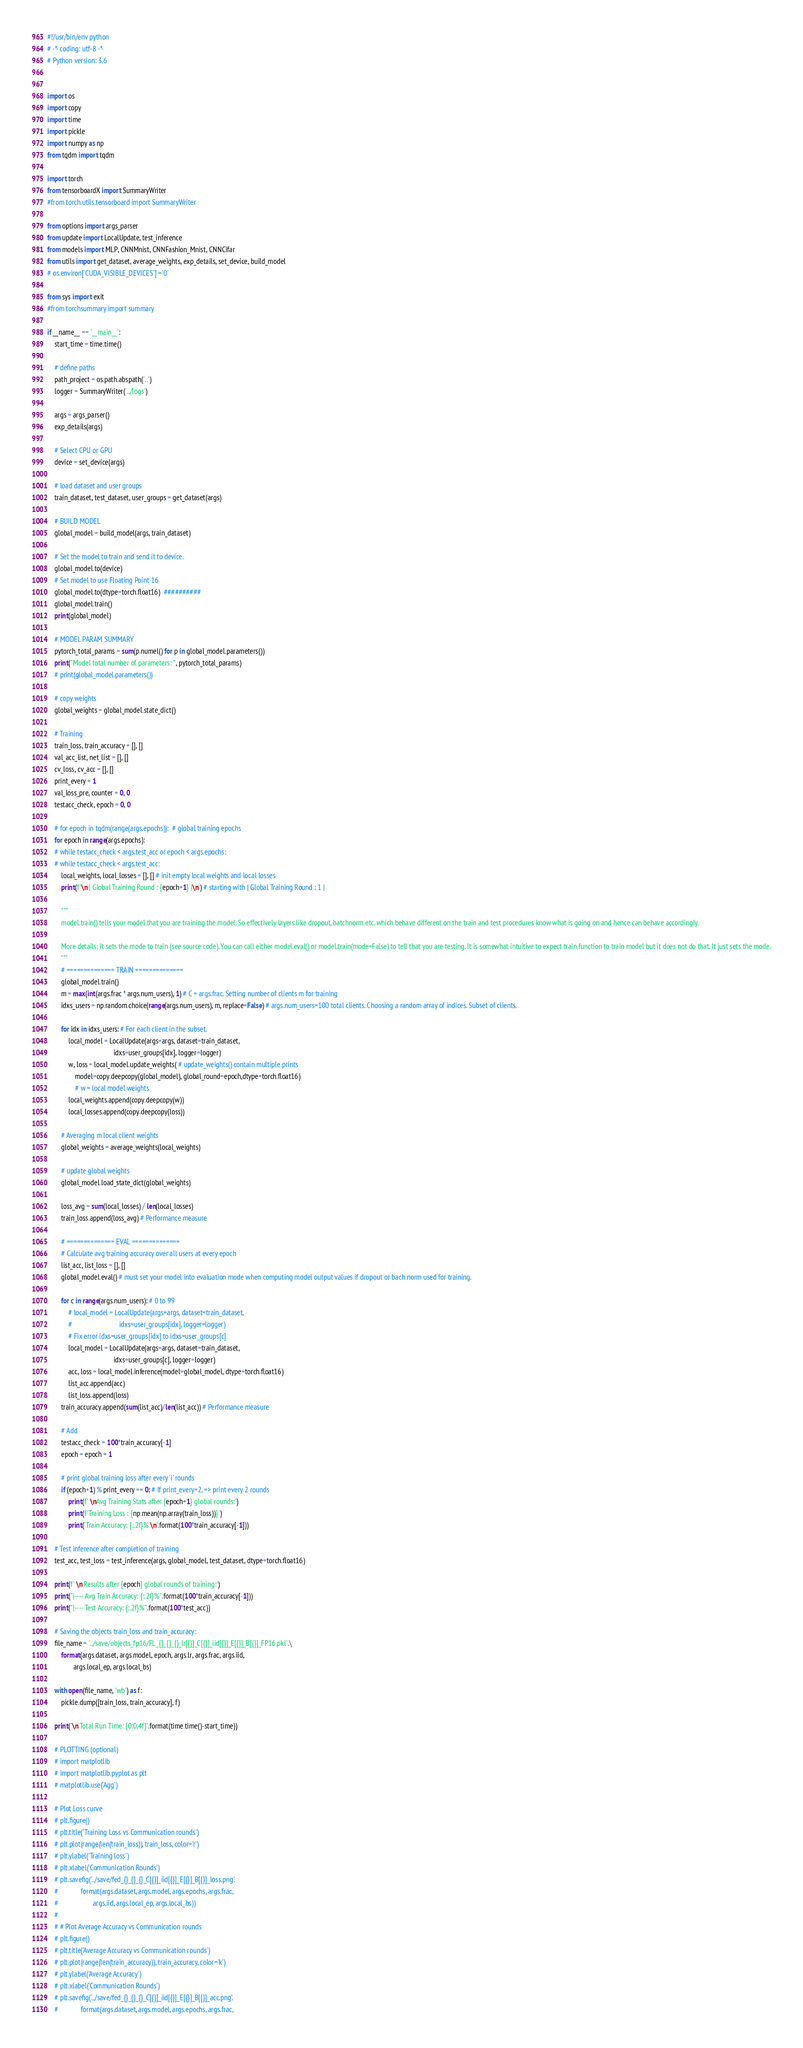<code> <loc_0><loc_0><loc_500><loc_500><_Python_>#!/usr/bin/env python
# -*- coding: utf-8 -*-
# Python version: 3.6


import os
import copy
import time
import pickle
import numpy as np
from tqdm import tqdm

import torch
from tensorboardX import SummaryWriter 
#from torch.utils.tensorboard import SummaryWriter

from options import args_parser
from update import LocalUpdate, test_inference
from models import MLP, CNNMnist, CNNFashion_Mnist, CNNCifar
from utils import get_dataset, average_weights, exp_details, set_device, build_model
# os.environ['CUDA_VISIBLE_DEVICES'] ='0'

from sys import exit
#from torchsummary import summary

if __name__ == '__main__':
    start_time = time.time()

    # define paths
    path_project = os.path.abspath('..')
    logger = SummaryWriter('../logs')

    args = args_parser()
    exp_details(args)

    # Select CPU or GPU
    device = set_device(args)

    # load dataset and user groups
    train_dataset, test_dataset, user_groups = get_dataset(args)

    # BUILD MODEL
    global_model = build_model(args, train_dataset)

    # Set the model to train and send it to device.
    global_model.to(device)
    # Set model to use Floating Point 16
    global_model.to(dtype=torch.float16)  ##########
    global_model.train()
    print(global_model)
    
    # MODEL PARAM SUMMARY
    pytorch_total_params = sum(p.numel() for p in global_model.parameters())
    print("Model total number of parameters: ", pytorch_total_params)
    # print(global_model.parameters())

    # copy weights
    global_weights = global_model.state_dict()

    # Training
    train_loss, train_accuracy = [], []
    val_acc_list, net_list = [], []
    cv_loss, cv_acc = [], []
    print_every = 1
    val_loss_pre, counter = 0, 0
    testacc_check, epoch = 0, 0 

    # for epoch in tqdm(range(args.epochs)):  # global training epochs
    for epoch in range(args.epochs):
    # while testacc_check < args.test_acc or epoch < args.epochs:
    # while testacc_check < args.test_acc:
        local_weights, local_losses = [], [] # init empty local weights and local losses
        print(f'\n | Global Training Round : {epoch+1} |\n') # starting with | Global Training Round : 1 |

        """
        model.train() tells your model that you are training the model. So effectively layers like dropout, batchnorm etc. which behave different on the train and test procedures know what is going on and hence can behave accordingly.

        More details: It sets the mode to train (see source code). You can call either model.eval() or model.train(mode=False) to tell that you are testing. It is somewhat intuitive to expect train function to train model but it does not do that. It just sets the mode.
        """
        # ============== TRAIN ============== 
        global_model.train()
        m = max(int(args.frac * args.num_users), 1) # C = args.frac. Setting number of clients m for training
        idxs_users = np.random.choice(range(args.num_users), m, replace=False) # args.num_users=100 total clients. Choosing a random array of indices. Subset of clients.

        for idx in idxs_users: # For each client in the subset.
            local_model = LocalUpdate(args=args, dataset=train_dataset,
                                      idxs=user_groups[idx], logger=logger)
            w, loss = local_model.update_weights( # update_weights() contain multiple prints
                model=copy.deepcopy(global_model), global_round=epoch,dtype=torch.float16) 
                # w = local model weights
            local_weights.append(copy.deepcopy(w))
            local_losses.append(copy.deepcopy(loss))

        # Averaging m local client weights
        global_weights = average_weights(local_weights)

        # update global weights
        global_model.load_state_dict(global_weights)

        loss_avg = sum(local_losses) / len(local_losses)
        train_loss.append(loss_avg) # Performance measure

        # ============== EVAL ============== 
        # Calculate avg training accuracy over all users at every epoch
        list_acc, list_loss = [], []
        global_model.eval() # must set your model into evaluation mode when computing model output values if dropout or bach norm used for training.

        for c in range(args.num_users): # 0 to 99
            # local_model = LocalUpdate(args=args, dataset=train_dataset,
            #                           idxs=user_groups[idx], logger=logger)
            # Fix error idxs=user_groups[idx] to idxs=user_groups[c]                                      
            local_model = LocalUpdate(args=args, dataset=train_dataset,
                                      idxs=user_groups[c], logger=logger)
            acc, loss = local_model.inference(model=global_model, dtype=torch.float16)
            list_acc.append(acc)
            list_loss.append(loss)
        train_accuracy.append(sum(list_acc)/len(list_acc)) # Performance measure

        # Add
        testacc_check = 100*train_accuracy[-1]
        epoch = epoch + 1

        # print global training loss after every 'i' rounds
        if (epoch+1) % print_every == 0: # If print_every=2, => print every 2 rounds
            print(f' \nAvg Training Stats after {epoch+1} global rounds:')
            print(f'Training Loss : {np.mean(np.array(train_loss))}')
            print('Train Accuracy: {:.2f}% \n'.format(100*train_accuracy[-1]))

    # Test inference after completion of training
    test_acc, test_loss = test_inference(args, global_model, test_dataset, dtype=torch.float16)

    print(f' \n Results after {epoch} global rounds of training:')
    print("|---- Avg Train Accuracy: {:.2f}%".format(100*train_accuracy[-1]))
    print("|---- Test Accuracy: {:.2f}%".format(100*test_acc))

    # Saving the objects train_loss and train_accuracy:
    file_name = '../save/objects_fp16/FL_{}_{}_{}_lr[{}]_C[{}]_iid[{}]_E[{}]_B[{}]_FP16.pkl'.\
        format(args.dataset, args.model, epoch, args.lr, args.frac, args.iid,
               args.local_ep, args.local_bs)

    with open(file_name, 'wb') as f:
        pickle.dump([train_loss, train_accuracy], f)

    print('\n Total Run Time: {0:0.4f}'.format(time.time()-start_time))

    # PLOTTING (optional)
    # import matplotlib
    # import matplotlib.pyplot as plt
    # matplotlib.use('Agg')

    # Plot Loss curve
    # plt.figure()
    # plt.title('Training Loss vs Communication rounds')
    # plt.plot(range(len(train_loss)), train_loss, color='r')
    # plt.ylabel('Training loss')
    # plt.xlabel('Communication Rounds')
    # plt.savefig('../save/fed_{}_{}_{}_C[{}]_iid[{}]_E[{}]_B[{}]_loss.png'.
    #             format(args.dataset, args.model, args.epochs, args.frac,
    #                    args.iid, args.local_ep, args.local_bs))
    #
    # # Plot Average Accuracy vs Communication rounds
    # plt.figure()
    # plt.title('Average Accuracy vs Communication rounds')
    # plt.plot(range(len(train_accuracy)), train_accuracy, color='k')
    # plt.ylabel('Average Accuracy')
    # plt.xlabel('Communication Rounds')
    # plt.savefig('../save/fed_{}_{}_{}_C[{}]_iid[{}]_E[{}]_B[{}]_acc.png'.
    #             format(args.dataset, args.model, args.epochs, args.frac,</code> 